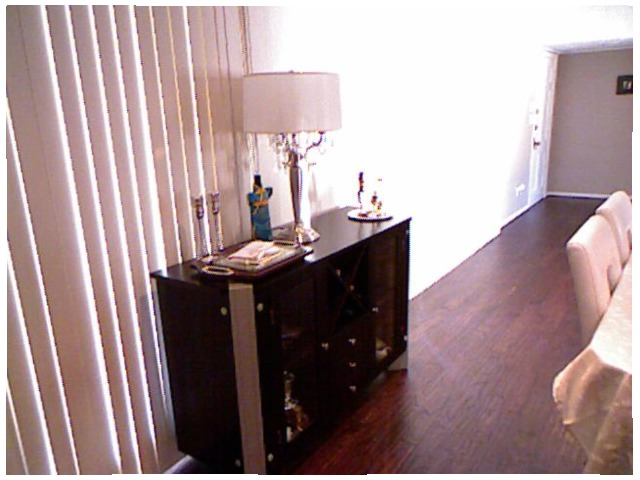<image>
Is there a lamp shade under the chair? No. The lamp shade is not positioned under the chair. The vertical relationship between these objects is different. Where is the lamp in relation to the dresser? Is it on the dresser? Yes. Looking at the image, I can see the lamp is positioned on top of the dresser, with the dresser providing support. Is the lamp behind the chair? Yes. From this viewpoint, the lamp is positioned behind the chair, with the chair partially or fully occluding the lamp. Is the toy to the right of the light? No. The toy is not to the right of the light. The horizontal positioning shows a different relationship. Is the light in the window? Yes. The light is contained within or inside the window, showing a containment relationship. 